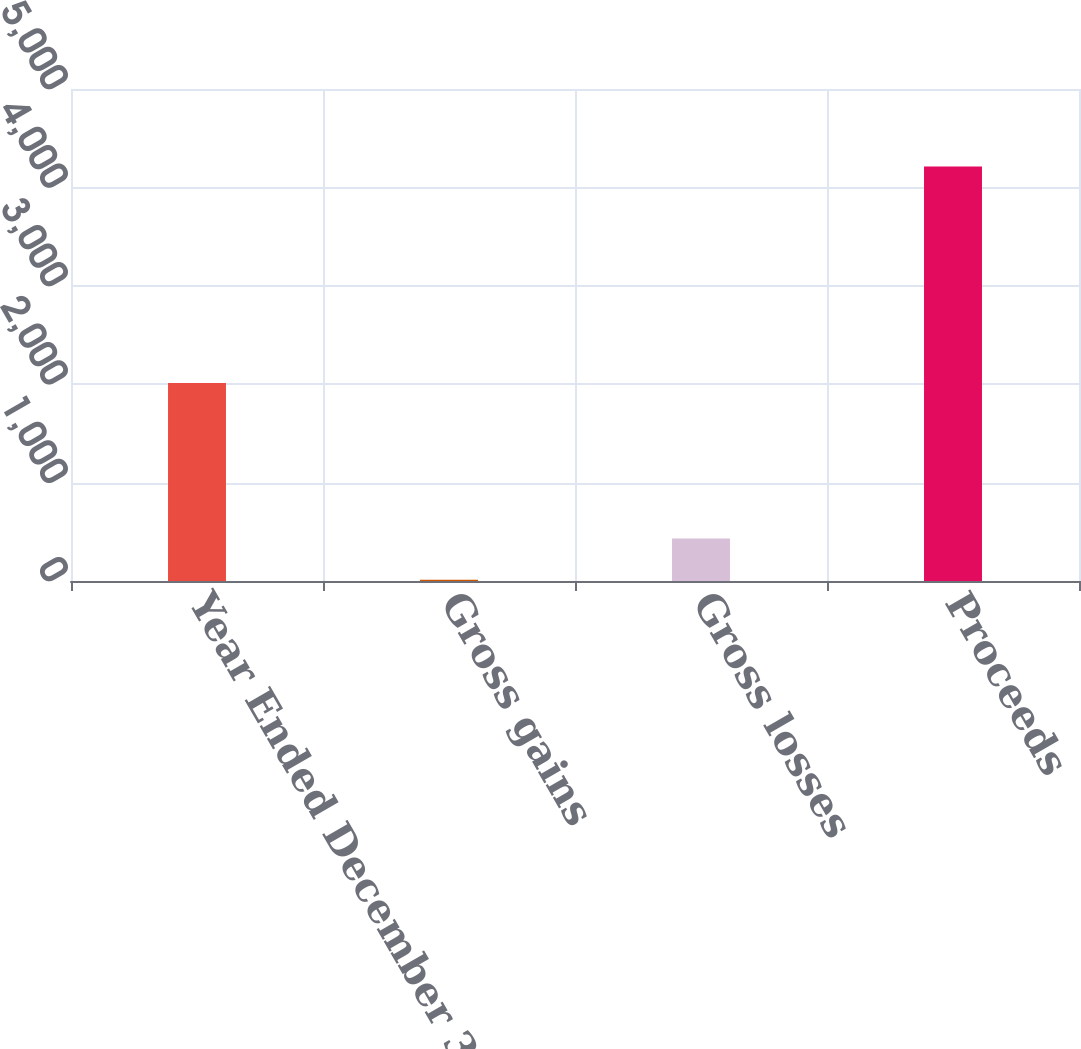<chart> <loc_0><loc_0><loc_500><loc_500><bar_chart><fcel>Year Ended December 31<fcel>Gross gains<fcel>Gross losses<fcel>Proceeds<nl><fcel>2013<fcel>12<fcel>432<fcel>4212<nl></chart> 